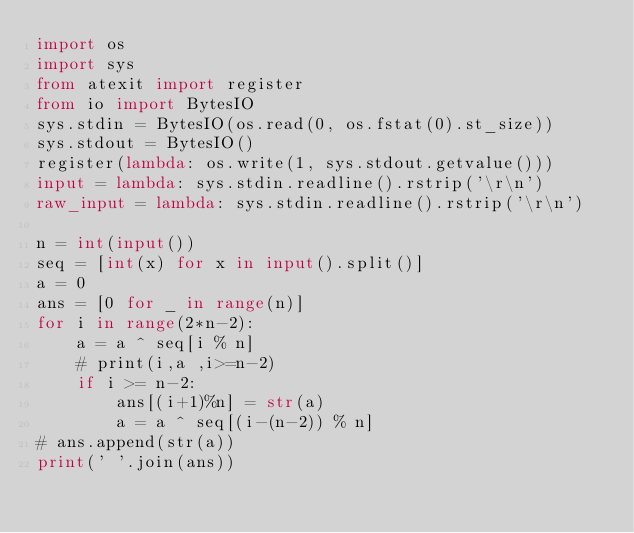Convert code to text. <code><loc_0><loc_0><loc_500><loc_500><_Python_>import os
import sys
from atexit import register
from io import BytesIO
sys.stdin = BytesIO(os.read(0, os.fstat(0).st_size))
sys.stdout = BytesIO()
register(lambda: os.write(1, sys.stdout.getvalue()))
input = lambda: sys.stdin.readline().rstrip('\r\n')
raw_input = lambda: sys.stdin.readline().rstrip('\r\n')

n = int(input())
seq = [int(x) for x in input().split()]
a = 0
ans = [0 for _ in range(n)]
for i in range(2*n-2):
    a = a ^ seq[i % n]
    # print(i,a ,i>=n-2)
    if i >= n-2:
        ans[(i+1)%n] = str(a)
        a = a ^ seq[(i-(n-2)) % n]
# ans.append(str(a))
print(' '.join(ans))</code> 